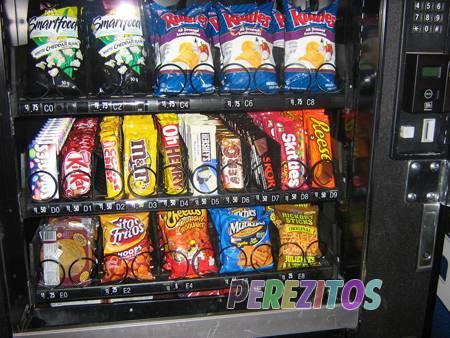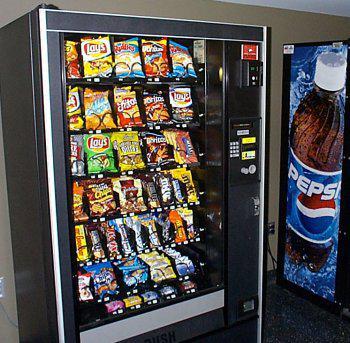The first image is the image on the left, the second image is the image on the right. For the images displayed, is the sentence "A bank of four vending machines is shown in one image." factually correct? Answer yes or no. No. 